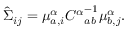Convert formula to latex. <formula><loc_0><loc_0><loc_500><loc_500>\begin{array} { r } { \hat { \Sigma } _ { i j } = \mu _ { a , i } ^ { \alpha } { C ^ { \alpha } } _ { a b } ^ { - 1 } \mu _ { b , j } ^ { \alpha } . } \end{array}</formula> 